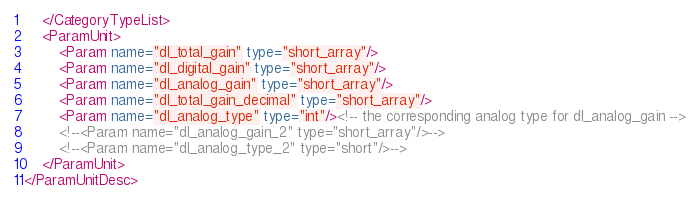<code> <loc_0><loc_0><loc_500><loc_500><_XML_>	</CategoryTypeList>
	<ParamUnit>
		<Param name="dl_total_gain" type="short_array"/>
		<Param name="dl_digital_gain" type="short_array"/>
		<Param name="dl_analog_gain" type="short_array"/>
		<Param name="dl_total_gain_decimal" type="short_array"/>
		<Param name="dl_analog_type" type="int"/><!-- the corresponding analog type for dl_analog_gain -->
		<!--<Param name="dl_analog_gain_2" type="short_array"/>-->
		<!--<Param name="dl_analog_type_2" type="short"/>-->
	</ParamUnit>
</ParamUnitDesc>
</code> 